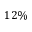<formula> <loc_0><loc_0><loc_500><loc_500>1 2 \%</formula> 